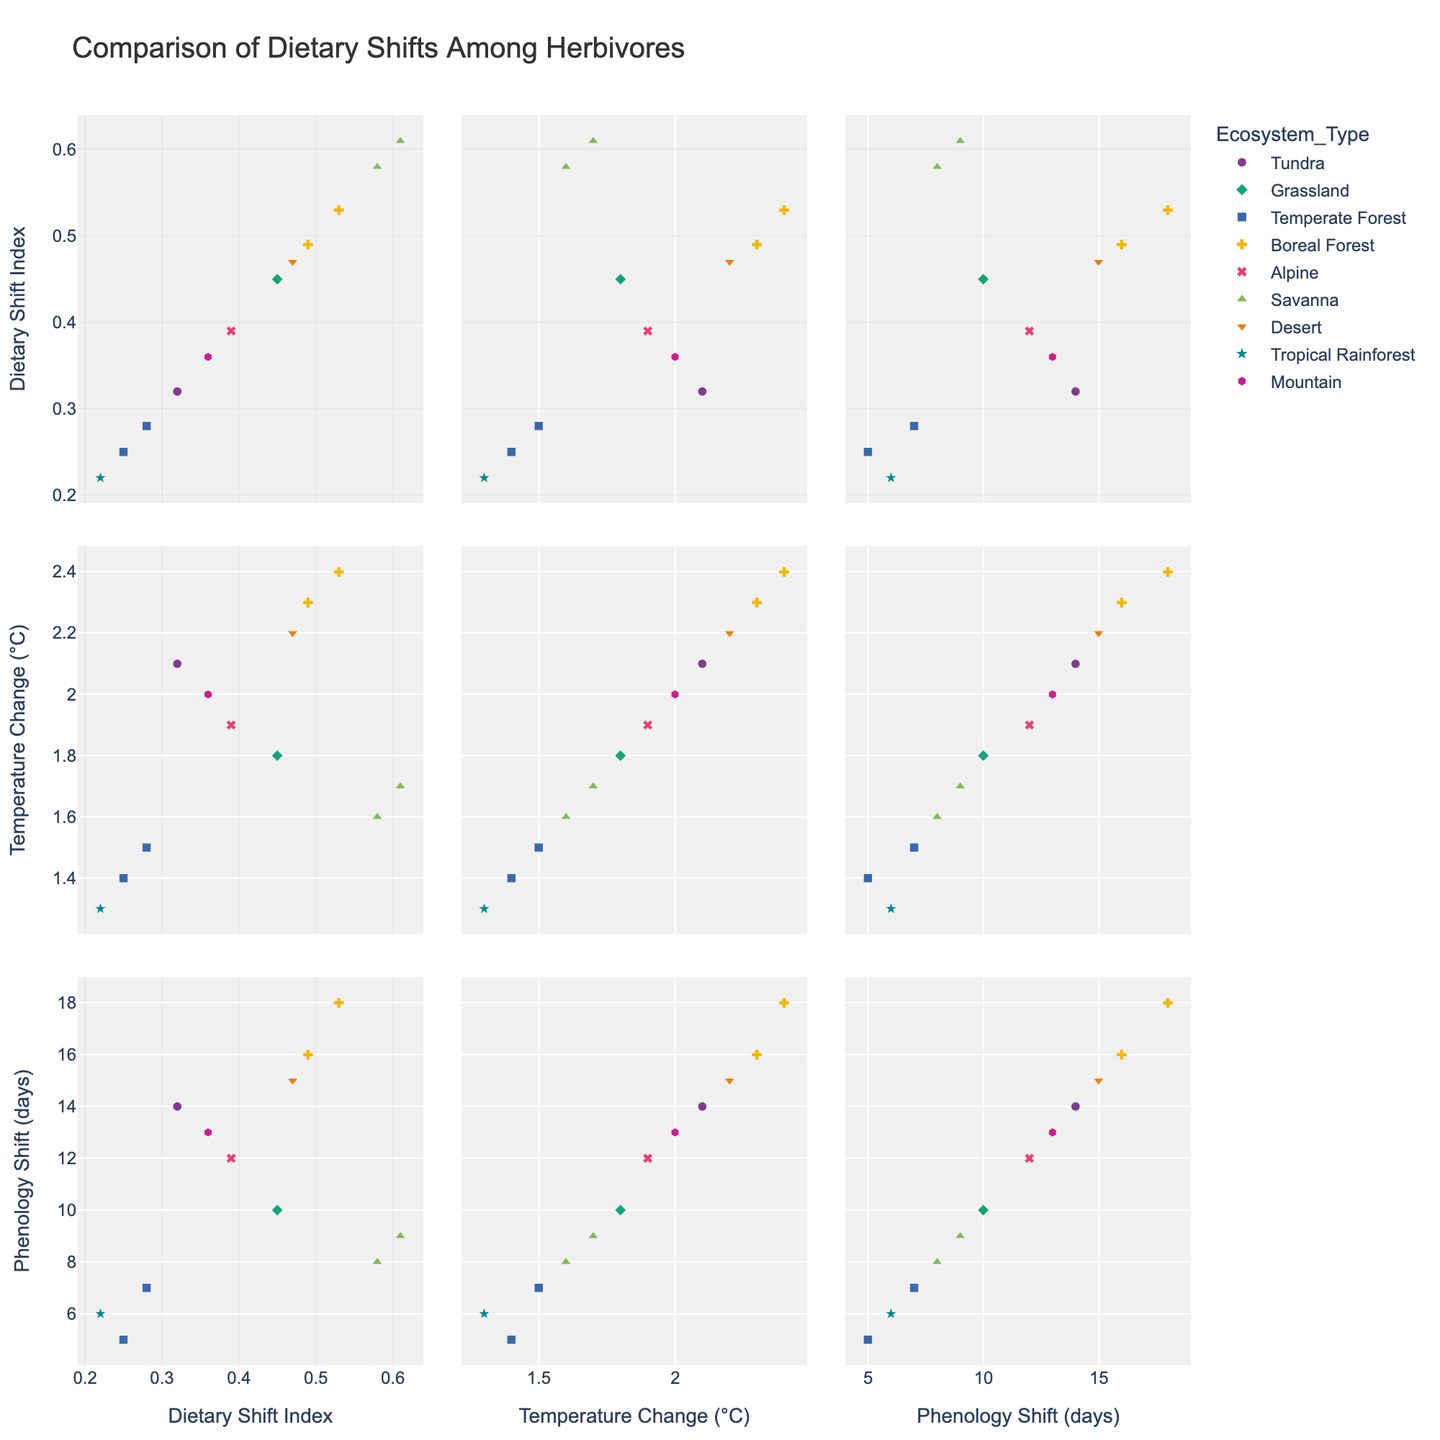What is the title of the plot? The title of the plot is displayed at the top and describes the overall content. The title here is given in the code as 'Comparison of Dietary Shifts Among Herbivores'.
Answer: Comparison of Dietary Shifts Among Herbivores How many dimensions or variables are plotted in the scatterplot matrix? The scatterplot matrix includes multiple scatterplots comparing each pair of variables. From the code, we can see that there are three dimensions: 'Dietary Shift Index', 'Temperature Change (°C)', and 'Phenology Shift (days)'.
Answer: 3 Which ecosystem type has the highest dietary shift index? Look for the scatterplot that shows 'Dietary Shift Index' on the y-axis and identify the point with the highest value. The color and symbol associated with that point will correspond to the ecosystem type. From the data, the highest dietary shift index is 0.61 for the Elephant in the Savanna.
Answer: Savanna Does the ‘Tundra’ ecosystem show higher dietary shift index values compared to the ‘Desert’ ecosystem? Compare the points representing the 'Tundra' (Arctic Fox) and 'Desert' (Red Kangaroo) in the sections of the scatterplot matrix that show 'Dietary Shift Index'. The dietary shift index for Arctic Fox (Tundra) is 0.32 while for Red Kangaroo (Desert) it is 0.47.
Answer: No What is the average phenology shift for species from the Boreal Forest ecosystem? Identify the data points from the Boreal Forest ecosystem (Reindeer and Moose), then compute the average of their 'Phenology Shift'. For Reindeer (18 days) and Moose (16 days): (18 + 16) / 2 = 17 days.
Answer: 17 days Which species experiences the highest temperature change, and what is its ecosystem type? Look for the point with the highest value on the 'Temperature Change' axis in the scatterplot matrix, and check the corresponding hover text to identify the species and its ecosystem type. The species with the highest temperature change is Reindeer with 2.4°C in the Boreal Forest.
Answer: Reindeer, Boreal Forest Are herbivores in the Savanna ecosystem displaying a notable trend between phenology shift and dietary shift index? Examine the scatterplot cells that plot 'Phenology Shift' against 'Dietary Shift Index' and look at the points that correspond to the Savanna ecosystem (symbol and color). Both Elephant and Wildebeest show medium to high values in both metrics, indicating a positive correlation.
Answer: Yes Among the alpine ecosystem species, what is the relationship between temperature change and phenology shift? Identify the points corresponding to the Alpine ecosystem (Mountain Goat) in the scatterplot that displays 'Temperature Change' versus 'Phenology Shift'. Both values (1.9 °C temperature change and 12 days phenology shift) should be observed for further interpretation.
Answer: Positive relationship Which species shows the smallest dietary shift index, and what is its corresponding temperature change? Find the point with the smallest value for 'Dietary Shift Index' on the relevant axis and check the hover text. The species with the smallest dietary shift index is Sloth with a value of 0.22 and a corresponding temperature change of 1.3°C.
Answer: Sloth, 1.3°C 